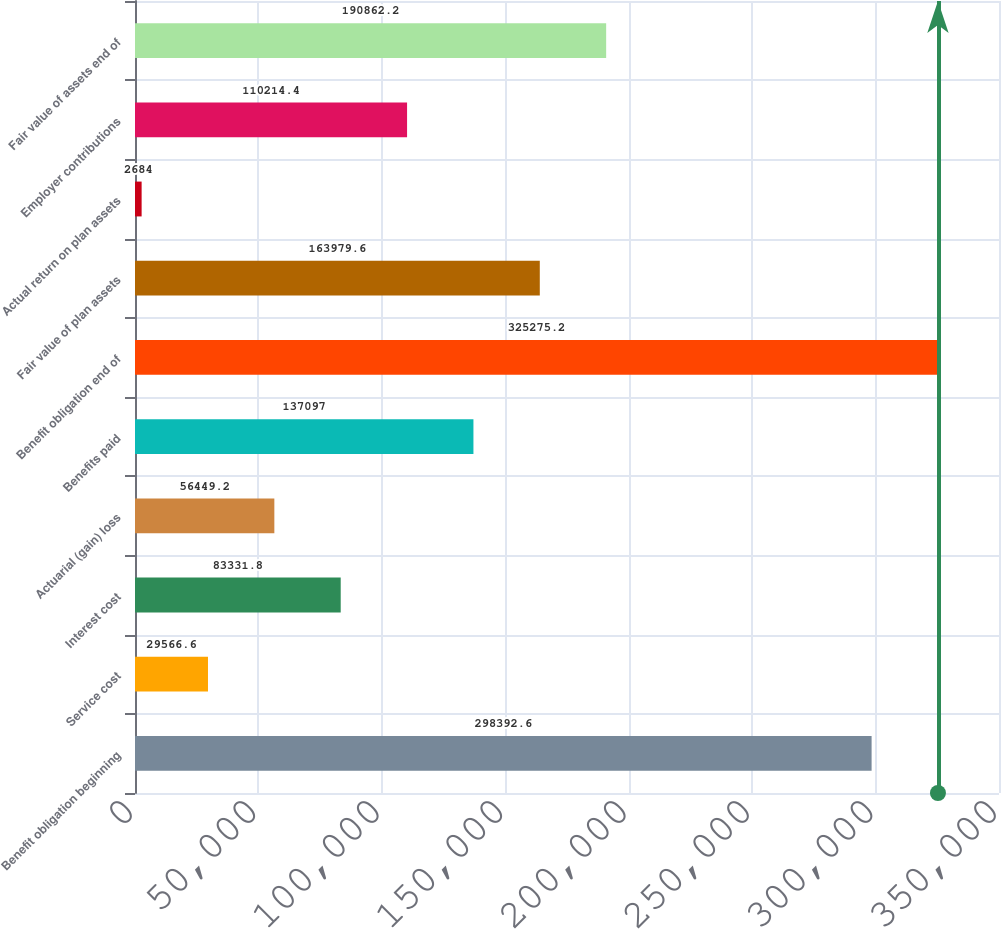<chart> <loc_0><loc_0><loc_500><loc_500><bar_chart><fcel>Benefit obligation beginning<fcel>Service cost<fcel>Interest cost<fcel>Actuarial (gain) loss<fcel>Benefits paid<fcel>Benefit obligation end of<fcel>Fair value of plan assets<fcel>Actual return on plan assets<fcel>Employer contributions<fcel>Fair value of assets end of<nl><fcel>298393<fcel>29566.6<fcel>83331.8<fcel>56449.2<fcel>137097<fcel>325275<fcel>163980<fcel>2684<fcel>110214<fcel>190862<nl></chart> 